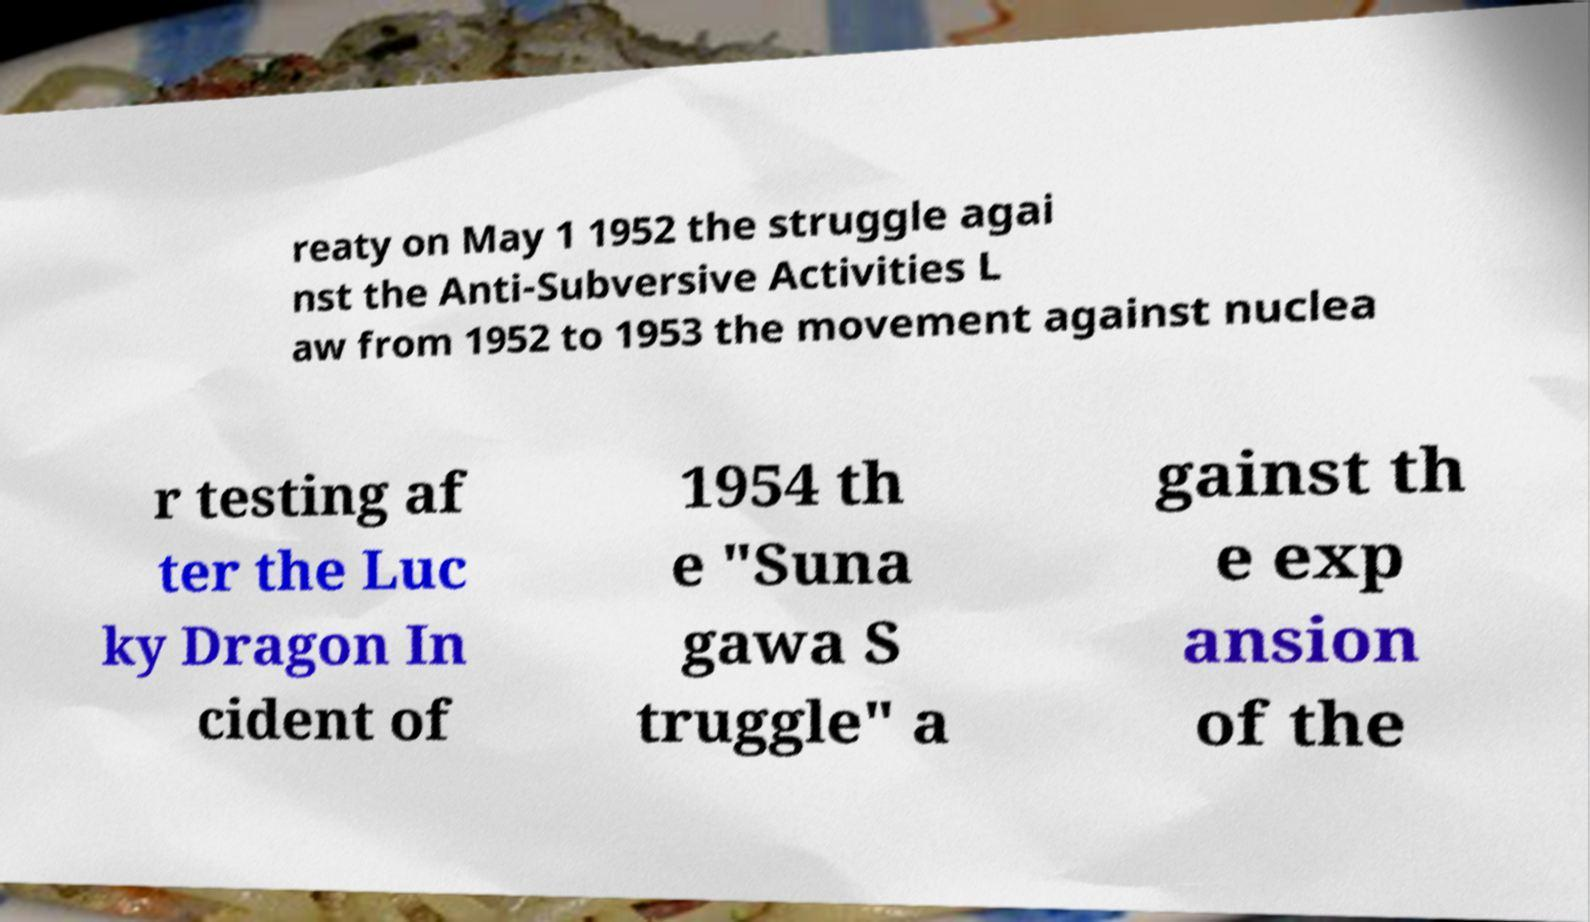Can you accurately transcribe the text from the provided image for me? reaty on May 1 1952 the struggle agai nst the Anti-Subversive Activities L aw from 1952 to 1953 the movement against nuclea r testing af ter the Luc ky Dragon In cident of 1954 th e "Suna gawa S truggle" a gainst th e exp ansion of the 